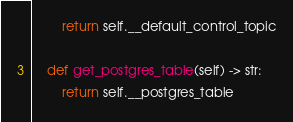Convert code to text. <code><loc_0><loc_0><loc_500><loc_500><_Python_>        return self.__default_control_topic

    def get_postgres_table(self) -> str:
        return self.__postgres_table
</code> 